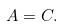<formula> <loc_0><loc_0><loc_500><loc_500>A = C .</formula> 